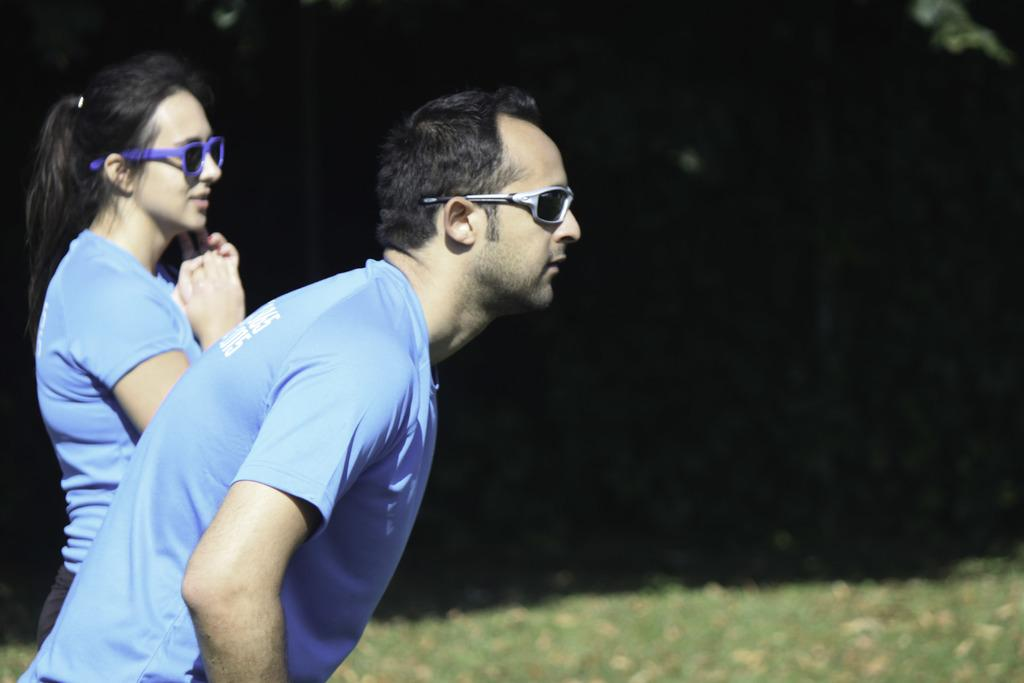How many people are in the image? There are two people in the image, one man and one woman. What are the people wearing? Both the man and the woman are wearing blue shirts. What is the color of the background in the image? There is a black background in the image. What type of natural environment is visible at the bottom of the image? There is grass visible at the bottom of the image. How many fowl are present in the image? There are no fowl present in the image; it only features two people wearing blue shirts against a black background with grass visible at the bottom. What type of car can be seen in the image? There is no car present in the image. 